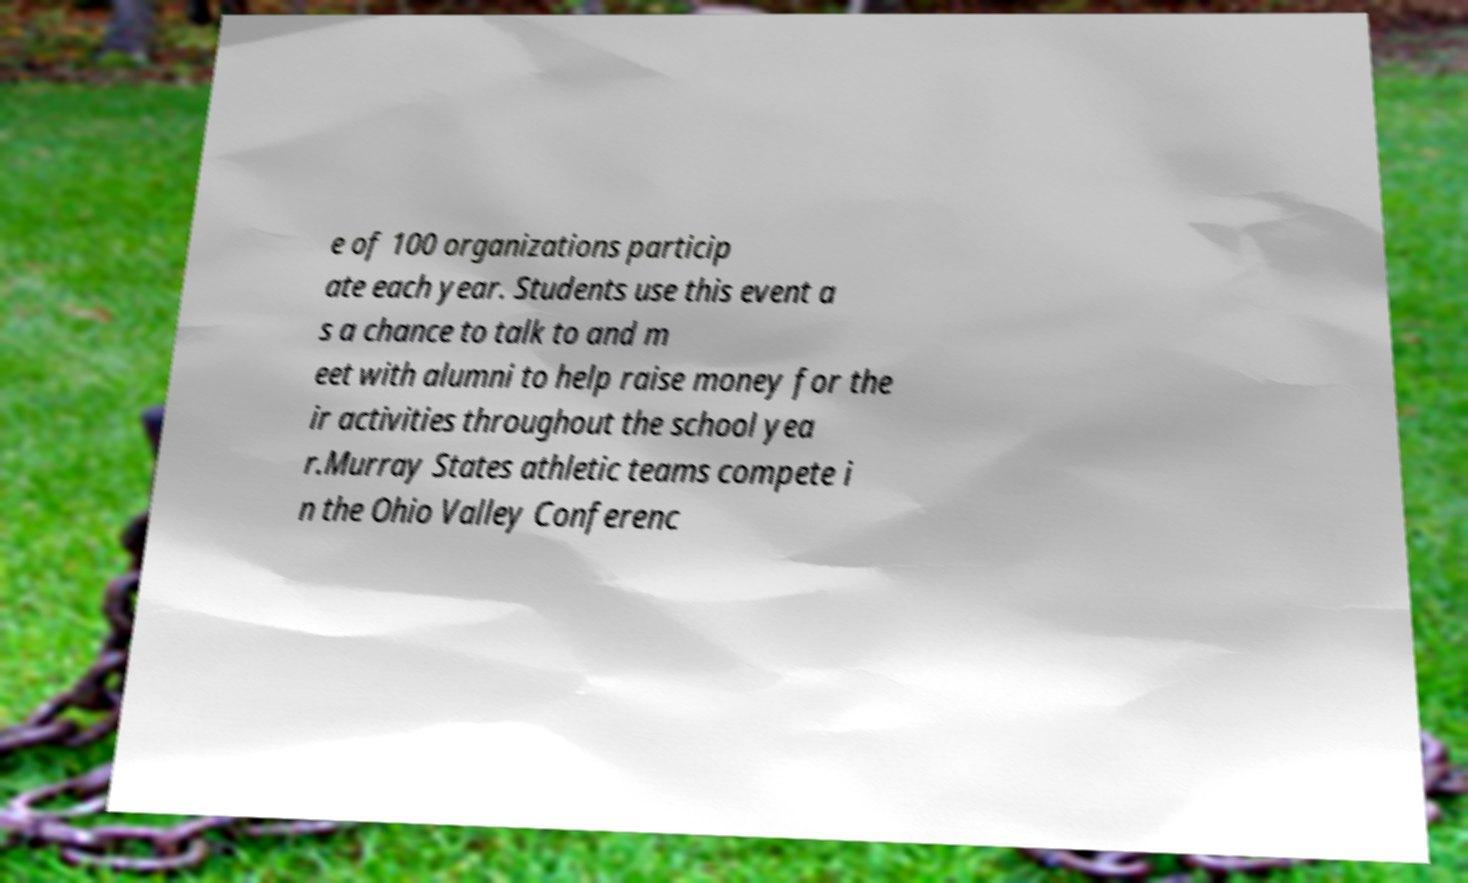Please read and relay the text visible in this image. What does it say? e of 100 organizations particip ate each year. Students use this event a s a chance to talk to and m eet with alumni to help raise money for the ir activities throughout the school yea r.Murray States athletic teams compete i n the Ohio Valley Conferenc 